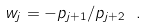Convert formula to latex. <formula><loc_0><loc_0><loc_500><loc_500>w _ { j } = - p _ { j + 1 } / p _ { j + 2 } \ .</formula> 